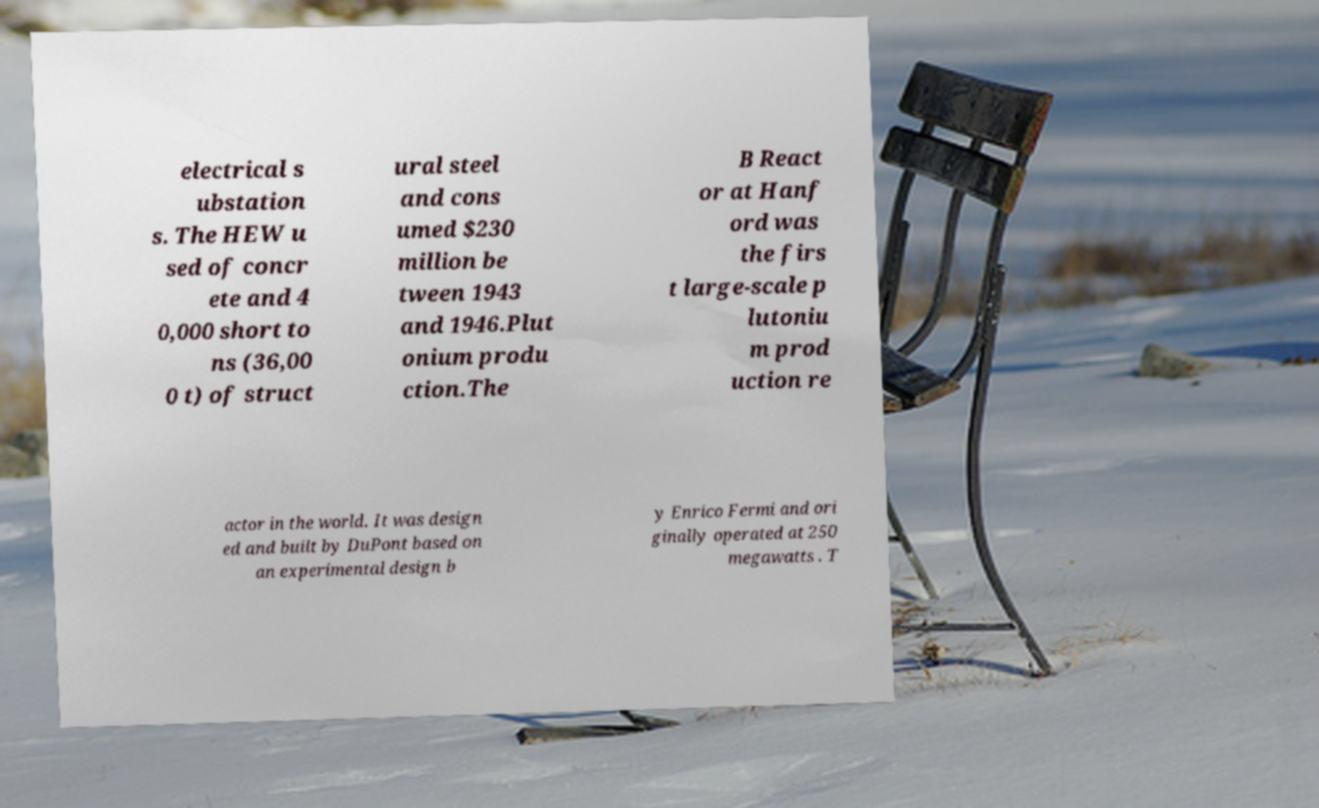Could you extract and type out the text from this image? electrical s ubstation s. The HEW u sed of concr ete and 4 0,000 short to ns (36,00 0 t) of struct ural steel and cons umed $230 million be tween 1943 and 1946.Plut onium produ ction.The B React or at Hanf ord was the firs t large-scale p lutoniu m prod uction re actor in the world. It was design ed and built by DuPont based on an experimental design b y Enrico Fermi and ori ginally operated at 250 megawatts . T 